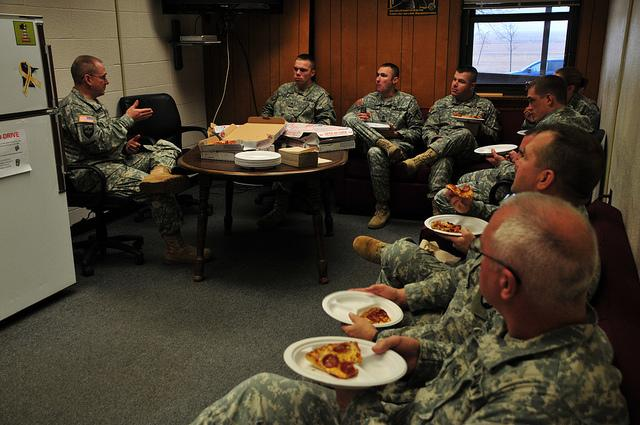What are they doing?

Choices:
A) answering questions
B) arguing
C) eating pizza
D) resting eating pizza 